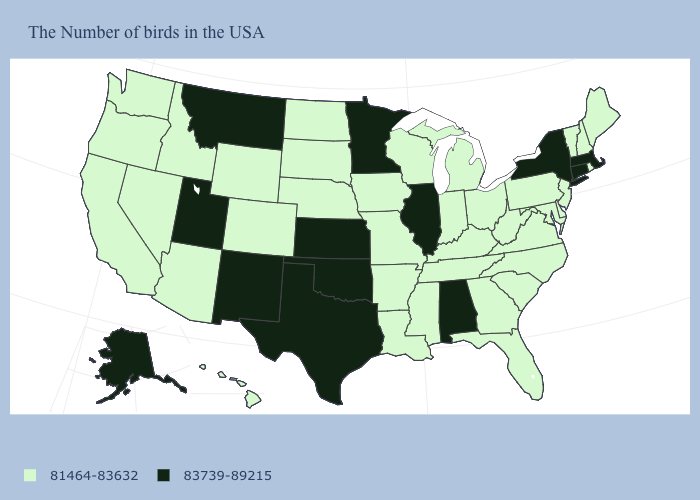Among the states that border Montana , which have the lowest value?
Answer briefly. South Dakota, North Dakota, Wyoming, Idaho. What is the value of Colorado?
Concise answer only. 81464-83632. Among the states that border Rhode Island , which have the highest value?
Quick response, please. Massachusetts, Connecticut. Does New Hampshire have a lower value than Minnesota?
Give a very brief answer. Yes. What is the value of Florida?
Write a very short answer. 81464-83632. Does the first symbol in the legend represent the smallest category?
Short answer required. Yes. Name the states that have a value in the range 81464-83632?
Answer briefly. Maine, Rhode Island, New Hampshire, Vermont, New Jersey, Delaware, Maryland, Pennsylvania, Virginia, North Carolina, South Carolina, West Virginia, Ohio, Florida, Georgia, Michigan, Kentucky, Indiana, Tennessee, Wisconsin, Mississippi, Louisiana, Missouri, Arkansas, Iowa, Nebraska, South Dakota, North Dakota, Wyoming, Colorado, Arizona, Idaho, Nevada, California, Washington, Oregon, Hawaii. Does Maryland have the highest value in the USA?
Quick response, please. No. Does the first symbol in the legend represent the smallest category?
Concise answer only. Yes. Name the states that have a value in the range 81464-83632?
Be succinct. Maine, Rhode Island, New Hampshire, Vermont, New Jersey, Delaware, Maryland, Pennsylvania, Virginia, North Carolina, South Carolina, West Virginia, Ohio, Florida, Georgia, Michigan, Kentucky, Indiana, Tennessee, Wisconsin, Mississippi, Louisiana, Missouri, Arkansas, Iowa, Nebraska, South Dakota, North Dakota, Wyoming, Colorado, Arizona, Idaho, Nevada, California, Washington, Oregon, Hawaii. Name the states that have a value in the range 81464-83632?
Answer briefly. Maine, Rhode Island, New Hampshire, Vermont, New Jersey, Delaware, Maryland, Pennsylvania, Virginia, North Carolina, South Carolina, West Virginia, Ohio, Florida, Georgia, Michigan, Kentucky, Indiana, Tennessee, Wisconsin, Mississippi, Louisiana, Missouri, Arkansas, Iowa, Nebraska, South Dakota, North Dakota, Wyoming, Colorado, Arizona, Idaho, Nevada, California, Washington, Oregon, Hawaii. Does Massachusetts have a higher value than West Virginia?
Concise answer only. Yes. Which states hav the highest value in the Northeast?
Answer briefly. Massachusetts, Connecticut, New York. 